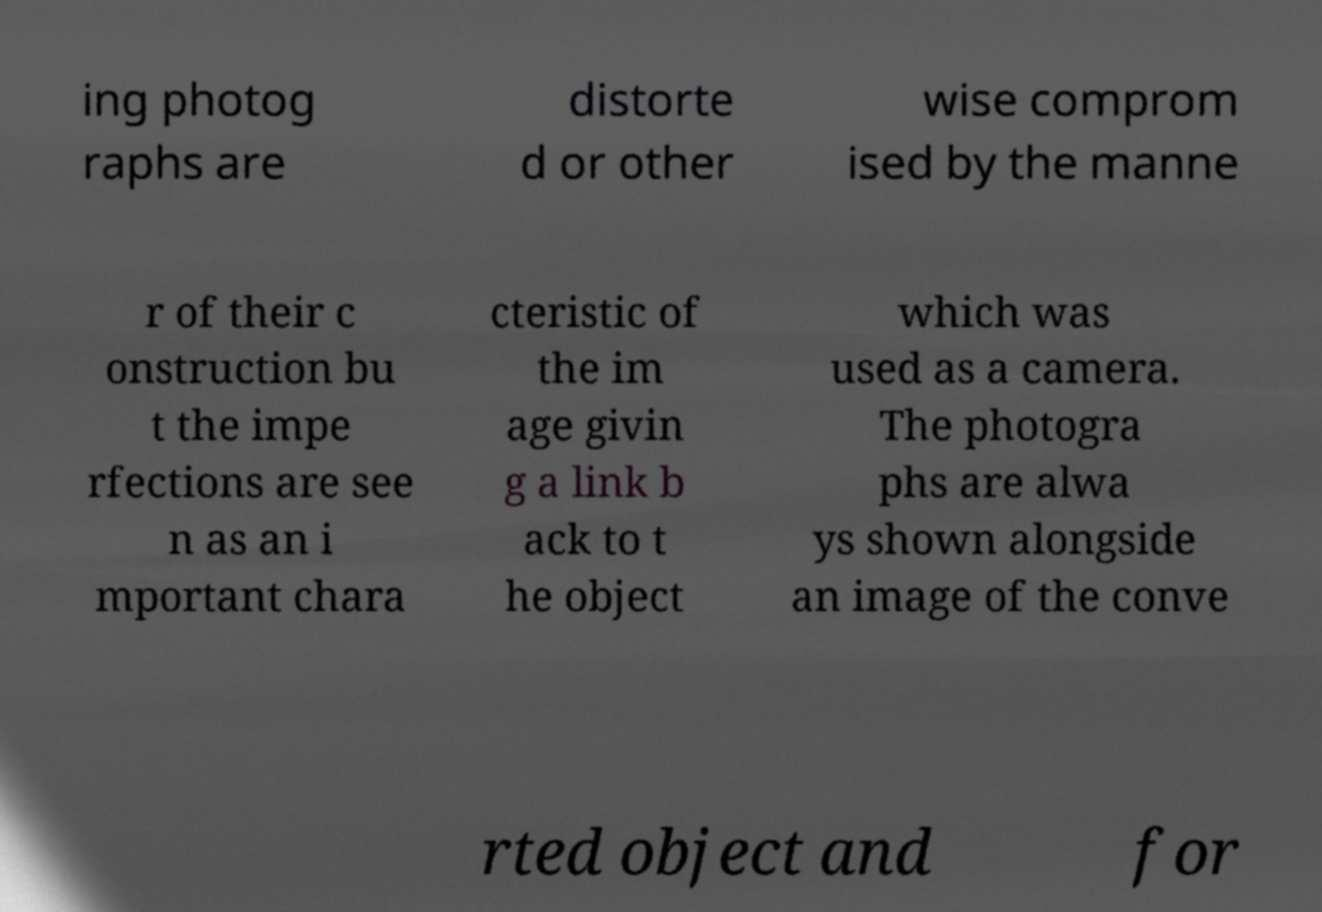There's text embedded in this image that I need extracted. Can you transcribe it verbatim? ing photog raphs are distorte d or other wise comprom ised by the manne r of their c onstruction bu t the impe rfections are see n as an i mportant chara cteristic of the im age givin g a link b ack to t he object which was used as a camera. The photogra phs are alwa ys shown alongside an image of the conve rted object and for 